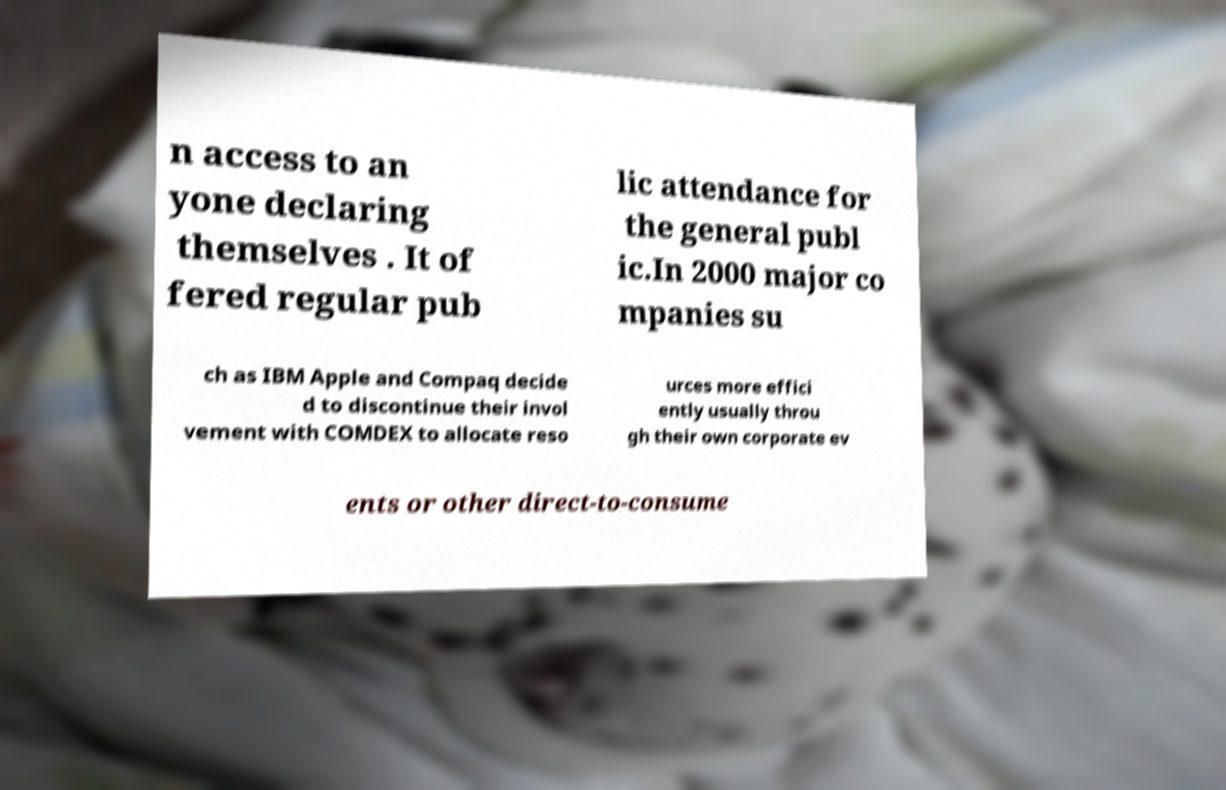Please read and relay the text visible in this image. What does it say? n access to an yone declaring themselves . It of fered regular pub lic attendance for the general publ ic.In 2000 major co mpanies su ch as IBM Apple and Compaq decide d to discontinue their invol vement with COMDEX to allocate reso urces more effici ently usually throu gh their own corporate ev ents or other direct-to-consume 